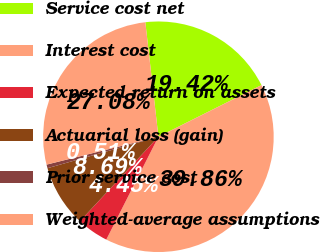Convert chart. <chart><loc_0><loc_0><loc_500><loc_500><pie_chart><fcel>Service cost net<fcel>Interest cost<fcel>Expected return on assets<fcel>Actuarial loss (gain)<fcel>Prior service cost<fcel>Weighted-average assumptions<nl><fcel>19.42%<fcel>39.86%<fcel>4.45%<fcel>8.69%<fcel>0.51%<fcel>27.08%<nl></chart> 